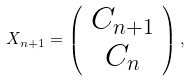<formula> <loc_0><loc_0><loc_500><loc_500>X _ { n + 1 } = \left ( \begin{array} { c } C _ { n + 1 } \\ C _ { n } \end{array} \right ) ,</formula> 